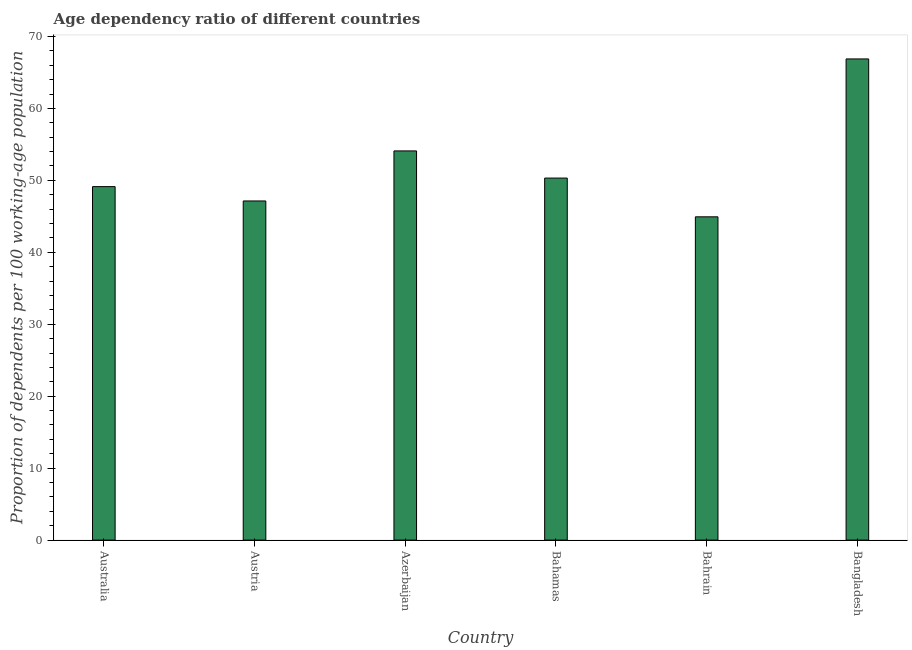What is the title of the graph?
Offer a very short reply. Age dependency ratio of different countries. What is the label or title of the X-axis?
Keep it short and to the point. Country. What is the label or title of the Y-axis?
Offer a very short reply. Proportion of dependents per 100 working-age population. What is the age dependency ratio in Azerbaijan?
Your response must be concise. 54.09. Across all countries, what is the maximum age dependency ratio?
Make the answer very short. 66.88. Across all countries, what is the minimum age dependency ratio?
Your answer should be very brief. 44.93. In which country was the age dependency ratio minimum?
Offer a terse response. Bahrain. What is the sum of the age dependency ratio?
Offer a terse response. 312.5. What is the difference between the age dependency ratio in Austria and Bahrain?
Ensure brevity in your answer.  2.21. What is the average age dependency ratio per country?
Ensure brevity in your answer.  52.08. What is the median age dependency ratio?
Offer a very short reply. 49.73. In how many countries, is the age dependency ratio greater than 58 ?
Offer a terse response. 1. What is the ratio of the age dependency ratio in Australia to that in Bangladesh?
Give a very brief answer. 0.73. Is the age dependency ratio in Bahamas less than that in Bangladesh?
Offer a terse response. Yes. What is the difference between the highest and the second highest age dependency ratio?
Give a very brief answer. 12.79. Is the sum of the age dependency ratio in Bahamas and Bahrain greater than the maximum age dependency ratio across all countries?
Keep it short and to the point. Yes. What is the difference between the highest and the lowest age dependency ratio?
Your response must be concise. 21.95. In how many countries, is the age dependency ratio greater than the average age dependency ratio taken over all countries?
Keep it short and to the point. 2. How many bars are there?
Your response must be concise. 6. Are all the bars in the graph horizontal?
Make the answer very short. No. How many countries are there in the graph?
Your response must be concise. 6. What is the Proportion of dependents per 100 working-age population in Australia?
Your answer should be very brief. 49.13. What is the Proportion of dependents per 100 working-age population of Austria?
Make the answer very short. 47.14. What is the Proportion of dependents per 100 working-age population of Azerbaijan?
Your answer should be compact. 54.09. What is the Proportion of dependents per 100 working-age population of Bahamas?
Provide a succinct answer. 50.32. What is the Proportion of dependents per 100 working-age population of Bahrain?
Your response must be concise. 44.93. What is the Proportion of dependents per 100 working-age population of Bangladesh?
Make the answer very short. 66.88. What is the difference between the Proportion of dependents per 100 working-age population in Australia and Austria?
Ensure brevity in your answer.  1.99. What is the difference between the Proportion of dependents per 100 working-age population in Australia and Azerbaijan?
Keep it short and to the point. -4.96. What is the difference between the Proportion of dependents per 100 working-age population in Australia and Bahamas?
Ensure brevity in your answer.  -1.19. What is the difference between the Proportion of dependents per 100 working-age population in Australia and Bahrain?
Ensure brevity in your answer.  4.2. What is the difference between the Proportion of dependents per 100 working-age population in Australia and Bangladesh?
Make the answer very short. -17.75. What is the difference between the Proportion of dependents per 100 working-age population in Austria and Azerbaijan?
Your response must be concise. -6.96. What is the difference between the Proportion of dependents per 100 working-age population in Austria and Bahamas?
Provide a succinct answer. -3.18. What is the difference between the Proportion of dependents per 100 working-age population in Austria and Bahrain?
Your answer should be very brief. 2.21. What is the difference between the Proportion of dependents per 100 working-age population in Austria and Bangladesh?
Your answer should be very brief. -19.74. What is the difference between the Proportion of dependents per 100 working-age population in Azerbaijan and Bahamas?
Keep it short and to the point. 3.78. What is the difference between the Proportion of dependents per 100 working-age population in Azerbaijan and Bahrain?
Make the answer very short. 9.16. What is the difference between the Proportion of dependents per 100 working-age population in Azerbaijan and Bangladesh?
Make the answer very short. -12.78. What is the difference between the Proportion of dependents per 100 working-age population in Bahamas and Bahrain?
Give a very brief answer. 5.39. What is the difference between the Proportion of dependents per 100 working-age population in Bahamas and Bangladesh?
Ensure brevity in your answer.  -16.56. What is the difference between the Proportion of dependents per 100 working-age population in Bahrain and Bangladesh?
Ensure brevity in your answer.  -21.95. What is the ratio of the Proportion of dependents per 100 working-age population in Australia to that in Austria?
Offer a terse response. 1.04. What is the ratio of the Proportion of dependents per 100 working-age population in Australia to that in Azerbaijan?
Make the answer very short. 0.91. What is the ratio of the Proportion of dependents per 100 working-age population in Australia to that in Bahamas?
Your answer should be compact. 0.98. What is the ratio of the Proportion of dependents per 100 working-age population in Australia to that in Bahrain?
Offer a very short reply. 1.09. What is the ratio of the Proportion of dependents per 100 working-age population in Australia to that in Bangladesh?
Your answer should be compact. 0.73. What is the ratio of the Proportion of dependents per 100 working-age population in Austria to that in Azerbaijan?
Your answer should be compact. 0.87. What is the ratio of the Proportion of dependents per 100 working-age population in Austria to that in Bahamas?
Give a very brief answer. 0.94. What is the ratio of the Proportion of dependents per 100 working-age population in Austria to that in Bahrain?
Your response must be concise. 1.05. What is the ratio of the Proportion of dependents per 100 working-age population in Austria to that in Bangladesh?
Your answer should be very brief. 0.7. What is the ratio of the Proportion of dependents per 100 working-age population in Azerbaijan to that in Bahamas?
Offer a very short reply. 1.07. What is the ratio of the Proportion of dependents per 100 working-age population in Azerbaijan to that in Bahrain?
Offer a terse response. 1.2. What is the ratio of the Proportion of dependents per 100 working-age population in Azerbaijan to that in Bangladesh?
Keep it short and to the point. 0.81. What is the ratio of the Proportion of dependents per 100 working-age population in Bahamas to that in Bahrain?
Your answer should be very brief. 1.12. What is the ratio of the Proportion of dependents per 100 working-age population in Bahamas to that in Bangladesh?
Ensure brevity in your answer.  0.75. What is the ratio of the Proportion of dependents per 100 working-age population in Bahrain to that in Bangladesh?
Offer a very short reply. 0.67. 